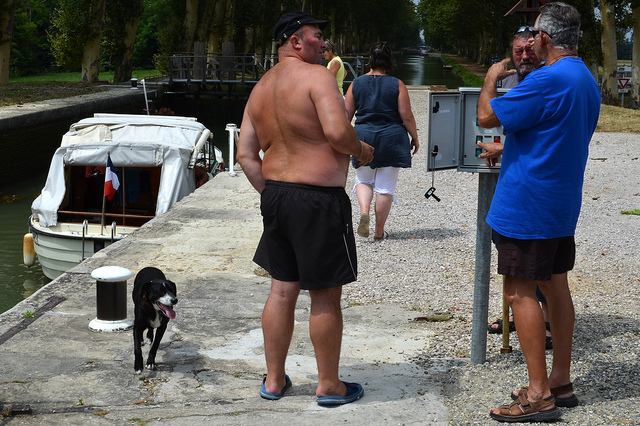<image>What country does the flag on the boat represent? I am not certain. The flag could represent a number of countries such as Italy, France, America, Yugoslavia or Mexico. What country does the flag on the boat represent? The flag on the boat represents Italy. 